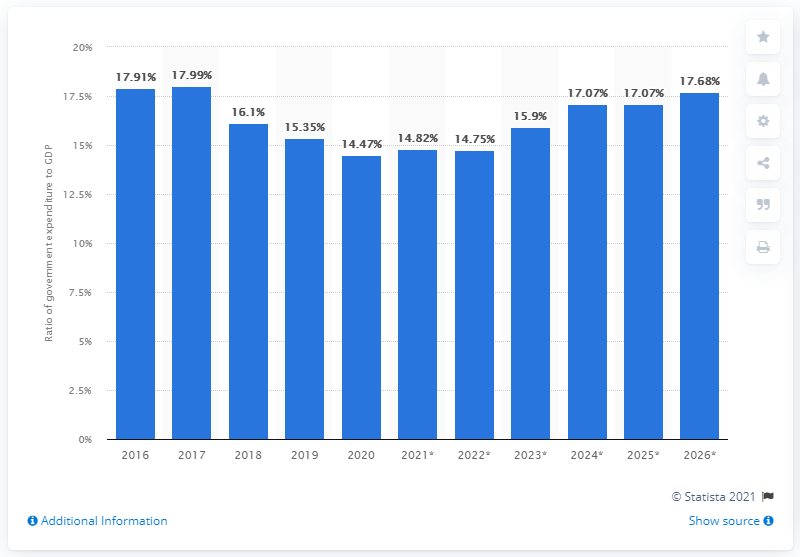Highlight a few significant elements in this photo. In 2020, government expenditure in Ethiopia accounted for 14.47% of the country's GDP. 